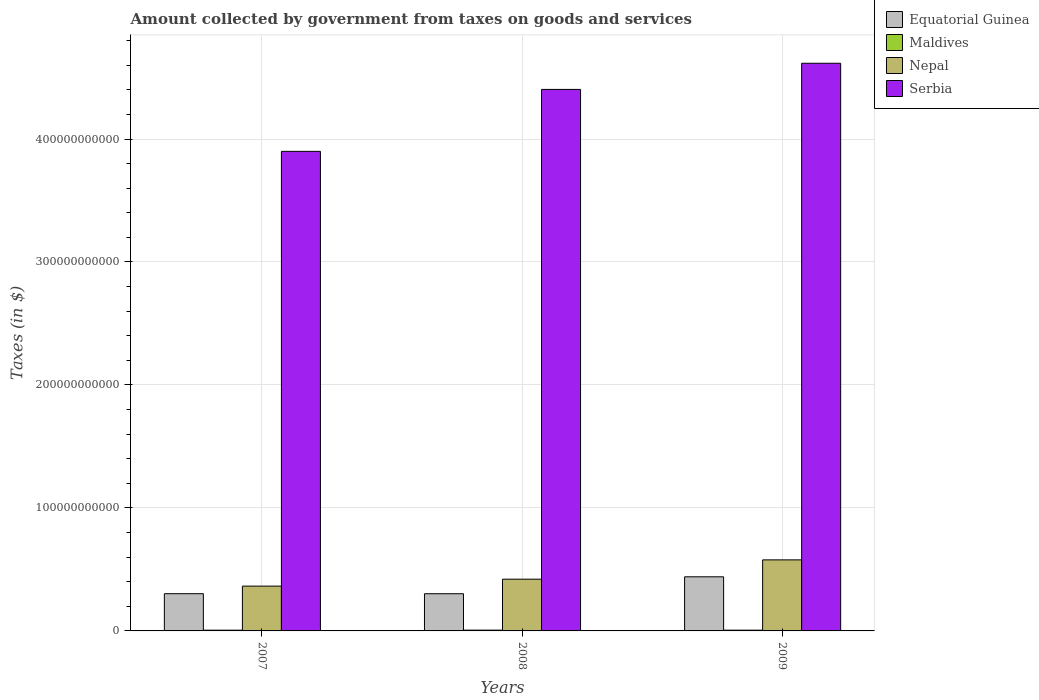How many bars are there on the 3rd tick from the right?
Give a very brief answer. 4. What is the label of the 2nd group of bars from the left?
Your answer should be very brief. 2008. In how many cases, is the number of bars for a given year not equal to the number of legend labels?
Offer a terse response. 0. What is the amount collected by government from taxes on goods and services in Serbia in 2007?
Provide a succinct answer. 3.90e+11. Across all years, what is the maximum amount collected by government from taxes on goods and services in Equatorial Guinea?
Your answer should be very brief. 4.40e+1. Across all years, what is the minimum amount collected by government from taxes on goods and services in Maldives?
Your answer should be very brief. 6.08e+08. In which year was the amount collected by government from taxes on goods and services in Maldives maximum?
Your response must be concise. 2008. What is the total amount collected by government from taxes on goods and services in Equatorial Guinea in the graph?
Ensure brevity in your answer.  1.05e+11. What is the difference between the amount collected by government from taxes on goods and services in Maldives in 2007 and that in 2009?
Keep it short and to the point. -2.60e+06. What is the difference between the amount collected by government from taxes on goods and services in Serbia in 2007 and the amount collected by government from taxes on goods and services in Nepal in 2008?
Make the answer very short. 3.48e+11. What is the average amount collected by government from taxes on goods and services in Maldives per year?
Keep it short and to the point. 6.19e+08. In the year 2007, what is the difference between the amount collected by government from taxes on goods and services in Serbia and amount collected by government from taxes on goods and services in Nepal?
Offer a very short reply. 3.54e+11. What is the ratio of the amount collected by government from taxes on goods and services in Nepal in 2007 to that in 2009?
Offer a very short reply. 0.63. Is the amount collected by government from taxes on goods and services in Nepal in 2007 less than that in 2009?
Ensure brevity in your answer.  Yes. What is the difference between the highest and the second highest amount collected by government from taxes on goods and services in Nepal?
Make the answer very short. 1.57e+1. What is the difference between the highest and the lowest amount collected by government from taxes on goods and services in Nepal?
Offer a very short reply. 2.13e+1. Is the sum of the amount collected by government from taxes on goods and services in Maldives in 2008 and 2009 greater than the maximum amount collected by government from taxes on goods and services in Equatorial Guinea across all years?
Your response must be concise. No. Is it the case that in every year, the sum of the amount collected by government from taxes on goods and services in Nepal and amount collected by government from taxes on goods and services in Equatorial Guinea is greater than the sum of amount collected by government from taxes on goods and services in Maldives and amount collected by government from taxes on goods and services in Serbia?
Provide a short and direct response. No. What does the 3rd bar from the left in 2009 represents?
Your response must be concise. Nepal. What does the 2nd bar from the right in 2009 represents?
Give a very brief answer. Nepal. How many bars are there?
Give a very brief answer. 12. Are all the bars in the graph horizontal?
Make the answer very short. No. How many years are there in the graph?
Make the answer very short. 3. What is the difference between two consecutive major ticks on the Y-axis?
Offer a very short reply. 1.00e+11. Are the values on the major ticks of Y-axis written in scientific E-notation?
Keep it short and to the point. No. Does the graph contain grids?
Make the answer very short. Yes. Where does the legend appear in the graph?
Give a very brief answer. Top right. How many legend labels are there?
Ensure brevity in your answer.  4. How are the legend labels stacked?
Provide a short and direct response. Vertical. What is the title of the graph?
Offer a very short reply. Amount collected by government from taxes on goods and services. What is the label or title of the Y-axis?
Your response must be concise. Taxes (in $). What is the Taxes (in $) of Equatorial Guinea in 2007?
Offer a very short reply. 3.03e+1. What is the Taxes (in $) in Maldives in 2007?
Offer a very short reply. 6.08e+08. What is the Taxes (in $) in Nepal in 2007?
Give a very brief answer. 3.64e+1. What is the Taxes (in $) of Serbia in 2007?
Keep it short and to the point. 3.90e+11. What is the Taxes (in $) in Equatorial Guinea in 2008?
Provide a short and direct response. 3.03e+1. What is the Taxes (in $) of Maldives in 2008?
Offer a terse response. 6.38e+08. What is the Taxes (in $) of Nepal in 2008?
Your answer should be very brief. 4.21e+1. What is the Taxes (in $) in Serbia in 2008?
Your response must be concise. 4.40e+11. What is the Taxes (in $) of Equatorial Guinea in 2009?
Provide a short and direct response. 4.40e+1. What is the Taxes (in $) of Maldives in 2009?
Make the answer very short. 6.10e+08. What is the Taxes (in $) of Nepal in 2009?
Provide a succinct answer. 5.78e+1. What is the Taxes (in $) in Serbia in 2009?
Keep it short and to the point. 4.62e+11. Across all years, what is the maximum Taxes (in $) of Equatorial Guinea?
Your answer should be compact. 4.40e+1. Across all years, what is the maximum Taxes (in $) of Maldives?
Provide a succinct answer. 6.38e+08. Across all years, what is the maximum Taxes (in $) in Nepal?
Make the answer very short. 5.78e+1. Across all years, what is the maximum Taxes (in $) of Serbia?
Provide a short and direct response. 4.62e+11. Across all years, what is the minimum Taxes (in $) of Equatorial Guinea?
Provide a succinct answer. 3.03e+1. Across all years, what is the minimum Taxes (in $) of Maldives?
Ensure brevity in your answer.  6.08e+08. Across all years, what is the minimum Taxes (in $) of Nepal?
Keep it short and to the point. 3.64e+1. Across all years, what is the minimum Taxes (in $) in Serbia?
Ensure brevity in your answer.  3.90e+11. What is the total Taxes (in $) of Equatorial Guinea in the graph?
Your response must be concise. 1.05e+11. What is the total Taxes (in $) of Maldives in the graph?
Provide a short and direct response. 1.86e+09. What is the total Taxes (in $) in Nepal in the graph?
Your response must be concise. 1.36e+11. What is the total Taxes (in $) of Serbia in the graph?
Give a very brief answer. 1.29e+12. What is the difference between the Taxes (in $) of Equatorial Guinea in 2007 and that in 2008?
Your response must be concise. 1.60e+07. What is the difference between the Taxes (in $) of Maldives in 2007 and that in 2008?
Keep it short and to the point. -2.97e+07. What is the difference between the Taxes (in $) of Nepal in 2007 and that in 2008?
Your answer should be compact. -5.64e+09. What is the difference between the Taxes (in $) of Serbia in 2007 and that in 2008?
Keep it short and to the point. -5.04e+1. What is the difference between the Taxes (in $) in Equatorial Guinea in 2007 and that in 2009?
Ensure brevity in your answer.  -1.37e+1. What is the difference between the Taxes (in $) in Maldives in 2007 and that in 2009?
Keep it short and to the point. -2.60e+06. What is the difference between the Taxes (in $) in Nepal in 2007 and that in 2009?
Offer a very short reply. -2.13e+1. What is the difference between the Taxes (in $) in Serbia in 2007 and that in 2009?
Provide a succinct answer. -7.16e+1. What is the difference between the Taxes (in $) in Equatorial Guinea in 2008 and that in 2009?
Offer a very short reply. -1.37e+1. What is the difference between the Taxes (in $) of Maldives in 2008 and that in 2009?
Offer a very short reply. 2.71e+07. What is the difference between the Taxes (in $) of Nepal in 2008 and that in 2009?
Offer a terse response. -1.57e+1. What is the difference between the Taxes (in $) in Serbia in 2008 and that in 2009?
Give a very brief answer. -2.13e+1. What is the difference between the Taxes (in $) of Equatorial Guinea in 2007 and the Taxes (in $) of Maldives in 2008?
Your response must be concise. 2.96e+1. What is the difference between the Taxes (in $) in Equatorial Guinea in 2007 and the Taxes (in $) in Nepal in 2008?
Your answer should be very brief. -1.18e+1. What is the difference between the Taxes (in $) of Equatorial Guinea in 2007 and the Taxes (in $) of Serbia in 2008?
Your answer should be very brief. -4.10e+11. What is the difference between the Taxes (in $) of Maldives in 2007 and the Taxes (in $) of Nepal in 2008?
Give a very brief answer. -4.15e+1. What is the difference between the Taxes (in $) in Maldives in 2007 and the Taxes (in $) in Serbia in 2008?
Offer a very short reply. -4.40e+11. What is the difference between the Taxes (in $) in Nepal in 2007 and the Taxes (in $) in Serbia in 2008?
Your answer should be very brief. -4.04e+11. What is the difference between the Taxes (in $) in Equatorial Guinea in 2007 and the Taxes (in $) in Maldives in 2009?
Offer a terse response. 2.97e+1. What is the difference between the Taxes (in $) of Equatorial Guinea in 2007 and the Taxes (in $) of Nepal in 2009?
Give a very brief answer. -2.75e+1. What is the difference between the Taxes (in $) of Equatorial Guinea in 2007 and the Taxes (in $) of Serbia in 2009?
Ensure brevity in your answer.  -4.31e+11. What is the difference between the Taxes (in $) in Maldives in 2007 and the Taxes (in $) in Nepal in 2009?
Offer a very short reply. -5.72e+1. What is the difference between the Taxes (in $) of Maldives in 2007 and the Taxes (in $) of Serbia in 2009?
Keep it short and to the point. -4.61e+11. What is the difference between the Taxes (in $) in Nepal in 2007 and the Taxes (in $) in Serbia in 2009?
Offer a very short reply. -4.25e+11. What is the difference between the Taxes (in $) in Equatorial Guinea in 2008 and the Taxes (in $) in Maldives in 2009?
Your answer should be compact. 2.96e+1. What is the difference between the Taxes (in $) of Equatorial Guinea in 2008 and the Taxes (in $) of Nepal in 2009?
Your answer should be very brief. -2.75e+1. What is the difference between the Taxes (in $) of Equatorial Guinea in 2008 and the Taxes (in $) of Serbia in 2009?
Ensure brevity in your answer.  -4.31e+11. What is the difference between the Taxes (in $) in Maldives in 2008 and the Taxes (in $) in Nepal in 2009?
Your response must be concise. -5.71e+1. What is the difference between the Taxes (in $) in Maldives in 2008 and the Taxes (in $) in Serbia in 2009?
Make the answer very short. -4.61e+11. What is the difference between the Taxes (in $) of Nepal in 2008 and the Taxes (in $) of Serbia in 2009?
Offer a terse response. -4.20e+11. What is the average Taxes (in $) in Equatorial Guinea per year?
Provide a short and direct response. 3.48e+1. What is the average Taxes (in $) in Maldives per year?
Provide a succinct answer. 6.19e+08. What is the average Taxes (in $) in Nepal per year?
Make the answer very short. 4.54e+1. What is the average Taxes (in $) of Serbia per year?
Your response must be concise. 4.31e+11. In the year 2007, what is the difference between the Taxes (in $) of Equatorial Guinea and Taxes (in $) of Maldives?
Provide a short and direct response. 2.97e+1. In the year 2007, what is the difference between the Taxes (in $) of Equatorial Guinea and Taxes (in $) of Nepal?
Your response must be concise. -6.17e+09. In the year 2007, what is the difference between the Taxes (in $) of Equatorial Guinea and Taxes (in $) of Serbia?
Your response must be concise. -3.60e+11. In the year 2007, what is the difference between the Taxes (in $) in Maldives and Taxes (in $) in Nepal?
Ensure brevity in your answer.  -3.58e+1. In the year 2007, what is the difference between the Taxes (in $) of Maldives and Taxes (in $) of Serbia?
Offer a terse response. -3.89e+11. In the year 2007, what is the difference between the Taxes (in $) in Nepal and Taxes (in $) in Serbia?
Your response must be concise. -3.54e+11. In the year 2008, what is the difference between the Taxes (in $) of Equatorial Guinea and Taxes (in $) of Maldives?
Your answer should be compact. 2.96e+1. In the year 2008, what is the difference between the Taxes (in $) of Equatorial Guinea and Taxes (in $) of Nepal?
Give a very brief answer. -1.18e+1. In the year 2008, what is the difference between the Taxes (in $) of Equatorial Guinea and Taxes (in $) of Serbia?
Make the answer very short. -4.10e+11. In the year 2008, what is the difference between the Taxes (in $) of Maldives and Taxes (in $) of Nepal?
Your answer should be compact. -4.14e+1. In the year 2008, what is the difference between the Taxes (in $) in Maldives and Taxes (in $) in Serbia?
Offer a very short reply. -4.40e+11. In the year 2008, what is the difference between the Taxes (in $) of Nepal and Taxes (in $) of Serbia?
Ensure brevity in your answer.  -3.98e+11. In the year 2009, what is the difference between the Taxes (in $) in Equatorial Guinea and Taxes (in $) in Maldives?
Your answer should be very brief. 4.34e+1. In the year 2009, what is the difference between the Taxes (in $) in Equatorial Guinea and Taxes (in $) in Nepal?
Give a very brief answer. -1.38e+1. In the year 2009, what is the difference between the Taxes (in $) in Equatorial Guinea and Taxes (in $) in Serbia?
Make the answer very short. -4.18e+11. In the year 2009, what is the difference between the Taxes (in $) of Maldives and Taxes (in $) of Nepal?
Your answer should be compact. -5.72e+1. In the year 2009, what is the difference between the Taxes (in $) in Maldives and Taxes (in $) in Serbia?
Your answer should be very brief. -4.61e+11. In the year 2009, what is the difference between the Taxes (in $) in Nepal and Taxes (in $) in Serbia?
Make the answer very short. -4.04e+11. What is the ratio of the Taxes (in $) in Maldives in 2007 to that in 2008?
Provide a succinct answer. 0.95. What is the ratio of the Taxes (in $) of Nepal in 2007 to that in 2008?
Your answer should be compact. 0.87. What is the ratio of the Taxes (in $) of Serbia in 2007 to that in 2008?
Your response must be concise. 0.89. What is the ratio of the Taxes (in $) of Equatorial Guinea in 2007 to that in 2009?
Keep it short and to the point. 0.69. What is the ratio of the Taxes (in $) in Maldives in 2007 to that in 2009?
Offer a terse response. 1. What is the ratio of the Taxes (in $) in Nepal in 2007 to that in 2009?
Your answer should be compact. 0.63. What is the ratio of the Taxes (in $) in Serbia in 2007 to that in 2009?
Ensure brevity in your answer.  0.84. What is the ratio of the Taxes (in $) in Equatorial Guinea in 2008 to that in 2009?
Offer a terse response. 0.69. What is the ratio of the Taxes (in $) in Maldives in 2008 to that in 2009?
Keep it short and to the point. 1.04. What is the ratio of the Taxes (in $) of Nepal in 2008 to that in 2009?
Your response must be concise. 0.73. What is the ratio of the Taxes (in $) in Serbia in 2008 to that in 2009?
Give a very brief answer. 0.95. What is the difference between the highest and the second highest Taxes (in $) of Equatorial Guinea?
Provide a succinct answer. 1.37e+1. What is the difference between the highest and the second highest Taxes (in $) of Maldives?
Offer a very short reply. 2.71e+07. What is the difference between the highest and the second highest Taxes (in $) of Nepal?
Give a very brief answer. 1.57e+1. What is the difference between the highest and the second highest Taxes (in $) of Serbia?
Make the answer very short. 2.13e+1. What is the difference between the highest and the lowest Taxes (in $) of Equatorial Guinea?
Offer a very short reply. 1.37e+1. What is the difference between the highest and the lowest Taxes (in $) in Maldives?
Give a very brief answer. 2.97e+07. What is the difference between the highest and the lowest Taxes (in $) of Nepal?
Your answer should be compact. 2.13e+1. What is the difference between the highest and the lowest Taxes (in $) of Serbia?
Provide a short and direct response. 7.16e+1. 